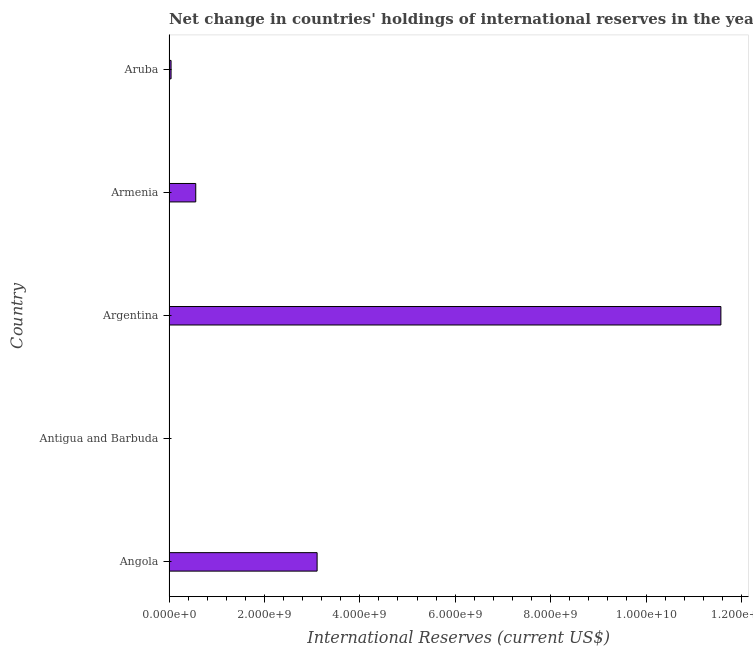What is the title of the graph?
Make the answer very short. Net change in countries' holdings of international reserves in the year 2007. What is the label or title of the X-axis?
Offer a terse response. International Reserves (current US$). What is the reserves and related items in Aruba?
Make the answer very short. 4.32e+07. Across all countries, what is the maximum reserves and related items?
Give a very brief answer. 1.16e+1. Across all countries, what is the minimum reserves and related items?
Your answer should be compact. 3.68e+05. In which country was the reserves and related items maximum?
Ensure brevity in your answer.  Argentina. In which country was the reserves and related items minimum?
Your response must be concise. Antigua and Barbuda. What is the sum of the reserves and related items?
Offer a very short reply. 1.53e+1. What is the difference between the reserves and related items in Antigua and Barbuda and Armenia?
Your answer should be very brief. -5.61e+08. What is the average reserves and related items per country?
Your response must be concise. 3.06e+09. What is the median reserves and related items?
Make the answer very short. 5.61e+08. What is the ratio of the reserves and related items in Argentina to that in Aruba?
Your answer should be very brief. 267.91. Is the reserves and related items in Argentina less than that in Aruba?
Offer a very short reply. No. Is the difference between the reserves and related items in Angola and Antigua and Barbuda greater than the difference between any two countries?
Offer a terse response. No. What is the difference between the highest and the second highest reserves and related items?
Keep it short and to the point. 8.46e+09. Is the sum of the reserves and related items in Antigua and Barbuda and Aruba greater than the maximum reserves and related items across all countries?
Offer a terse response. No. What is the difference between the highest and the lowest reserves and related items?
Offer a terse response. 1.16e+1. How many bars are there?
Your answer should be very brief. 5. What is the International Reserves (current US$) of Angola?
Provide a succinct answer. 3.10e+09. What is the International Reserves (current US$) in Antigua and Barbuda?
Provide a succinct answer. 3.68e+05. What is the International Reserves (current US$) in Argentina?
Provide a succinct answer. 1.16e+1. What is the International Reserves (current US$) in Armenia?
Offer a terse response. 5.61e+08. What is the International Reserves (current US$) in Aruba?
Give a very brief answer. 4.32e+07. What is the difference between the International Reserves (current US$) in Angola and Antigua and Barbuda?
Your answer should be compact. 3.10e+09. What is the difference between the International Reserves (current US$) in Angola and Argentina?
Provide a short and direct response. -8.46e+09. What is the difference between the International Reserves (current US$) in Angola and Armenia?
Provide a short and direct response. 2.54e+09. What is the difference between the International Reserves (current US$) in Angola and Aruba?
Provide a short and direct response. 3.06e+09. What is the difference between the International Reserves (current US$) in Antigua and Barbuda and Argentina?
Your answer should be very brief. -1.16e+1. What is the difference between the International Reserves (current US$) in Antigua and Barbuda and Armenia?
Make the answer very short. -5.61e+08. What is the difference between the International Reserves (current US$) in Antigua and Barbuda and Aruba?
Offer a very short reply. -4.28e+07. What is the difference between the International Reserves (current US$) in Argentina and Armenia?
Give a very brief answer. 1.10e+1. What is the difference between the International Reserves (current US$) in Argentina and Aruba?
Your answer should be very brief. 1.15e+1. What is the difference between the International Reserves (current US$) in Armenia and Aruba?
Your answer should be very brief. 5.18e+08. What is the ratio of the International Reserves (current US$) in Angola to that in Antigua and Barbuda?
Offer a terse response. 8426. What is the ratio of the International Reserves (current US$) in Angola to that in Argentina?
Provide a succinct answer. 0.27. What is the ratio of the International Reserves (current US$) in Angola to that in Armenia?
Your response must be concise. 5.54. What is the ratio of the International Reserves (current US$) in Angola to that in Aruba?
Keep it short and to the point. 71.9. What is the ratio of the International Reserves (current US$) in Antigua and Barbuda to that in Argentina?
Your answer should be very brief. 0. What is the ratio of the International Reserves (current US$) in Antigua and Barbuda to that in Aruba?
Offer a terse response. 0.01. What is the ratio of the International Reserves (current US$) in Argentina to that in Armenia?
Make the answer very short. 20.62. What is the ratio of the International Reserves (current US$) in Argentina to that in Aruba?
Offer a terse response. 267.91. What is the ratio of the International Reserves (current US$) in Armenia to that in Aruba?
Provide a succinct answer. 12.99. 